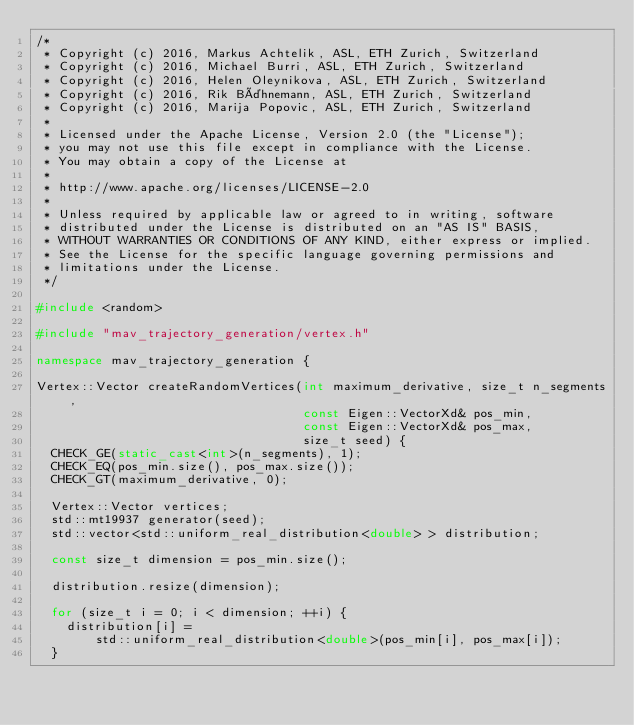Convert code to text. <code><loc_0><loc_0><loc_500><loc_500><_C++_>/*
 * Copyright (c) 2016, Markus Achtelik, ASL, ETH Zurich, Switzerland
 * Copyright (c) 2016, Michael Burri, ASL, ETH Zurich, Switzerland
 * Copyright (c) 2016, Helen Oleynikova, ASL, ETH Zurich, Switzerland
 * Copyright (c) 2016, Rik Bähnemann, ASL, ETH Zurich, Switzerland
 * Copyright (c) 2016, Marija Popovic, ASL, ETH Zurich, Switzerland
 *
 * Licensed under the Apache License, Version 2.0 (the "License");
 * you may not use this file except in compliance with the License.
 * You may obtain a copy of the License at
 *
 * http://www.apache.org/licenses/LICENSE-2.0
 *
 * Unless required by applicable law or agreed to in writing, software
 * distributed under the License is distributed on an "AS IS" BASIS,
 * WITHOUT WARRANTIES OR CONDITIONS OF ANY KIND, either express or implied.
 * See the License for the specific language governing permissions and
 * limitations under the License.
 */

#include <random>

#include "mav_trajectory_generation/vertex.h"

namespace mav_trajectory_generation {

Vertex::Vector createRandomVertices(int maximum_derivative, size_t n_segments,
                                    const Eigen::VectorXd& pos_min,
                                    const Eigen::VectorXd& pos_max,
                                    size_t seed) {
  CHECK_GE(static_cast<int>(n_segments), 1);
  CHECK_EQ(pos_min.size(), pos_max.size());
  CHECK_GT(maximum_derivative, 0);

  Vertex::Vector vertices;
  std::mt19937 generator(seed);
  std::vector<std::uniform_real_distribution<double> > distribution;

  const size_t dimension = pos_min.size();

  distribution.resize(dimension);

  for (size_t i = 0; i < dimension; ++i) {
    distribution[i] =
        std::uniform_real_distribution<double>(pos_min[i], pos_max[i]);
  }
</code> 